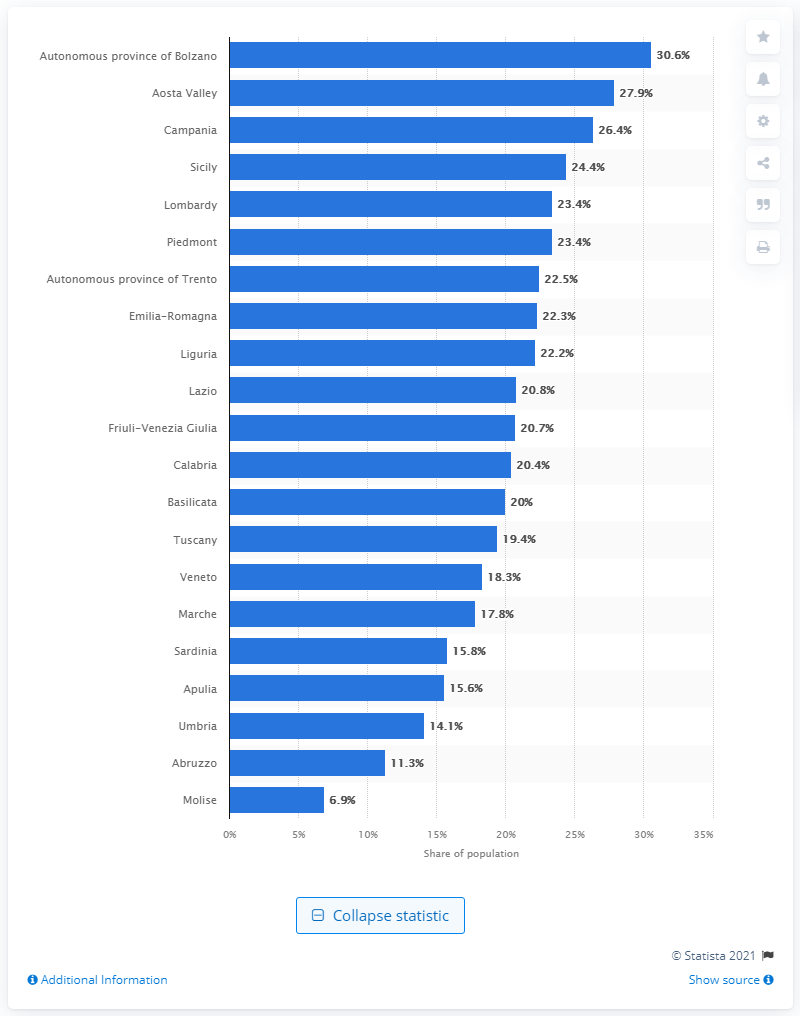Highlight a few significant elements in this photo. In the southern region of Italy, Molise has the lowest percentage of people who rent houses. 